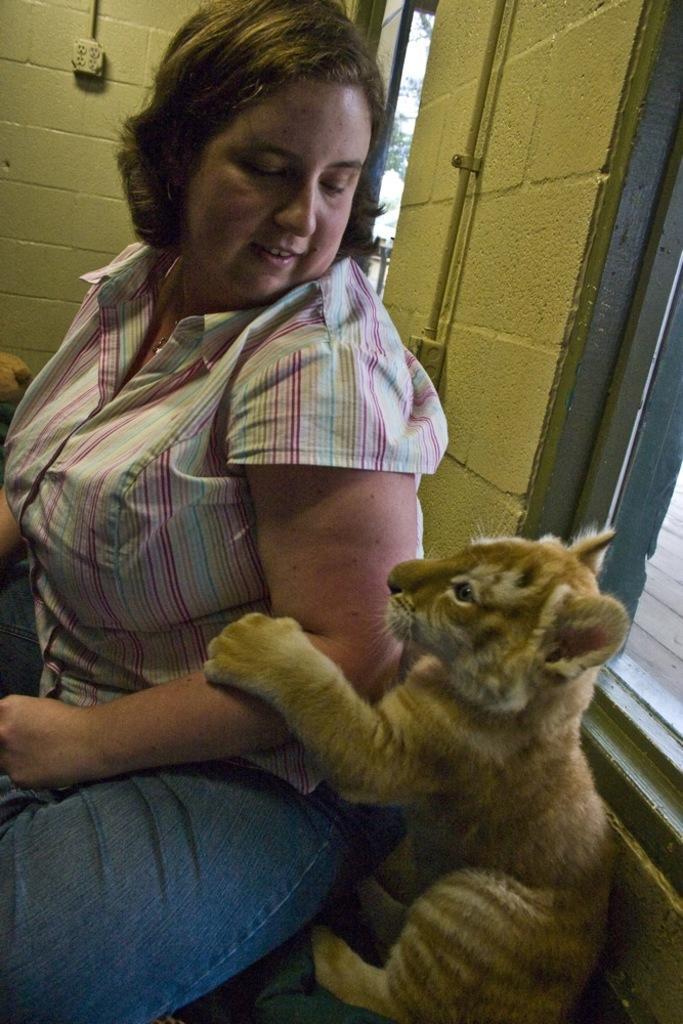In one or two sentences, can you explain what this image depicts? This picture shows a woman seated and we see a lion cub. 